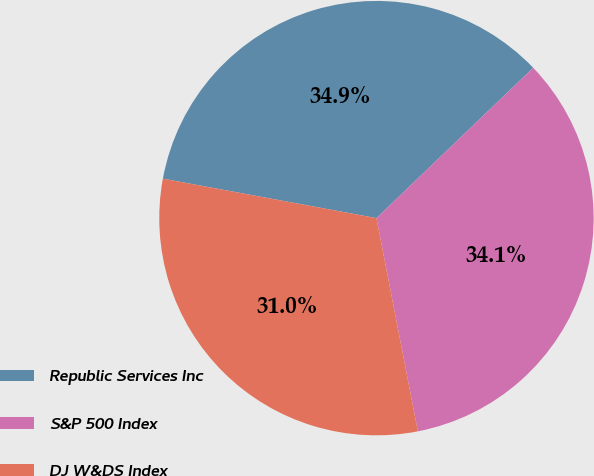<chart> <loc_0><loc_0><loc_500><loc_500><pie_chart><fcel>Republic Services Inc<fcel>S&P 500 Index<fcel>DJ W&DS Index<nl><fcel>34.92%<fcel>34.11%<fcel>30.96%<nl></chart> 